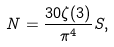<formula> <loc_0><loc_0><loc_500><loc_500>N = \frac { 3 0 \zeta ( 3 ) } { \pi ^ { 4 } } S ,</formula> 